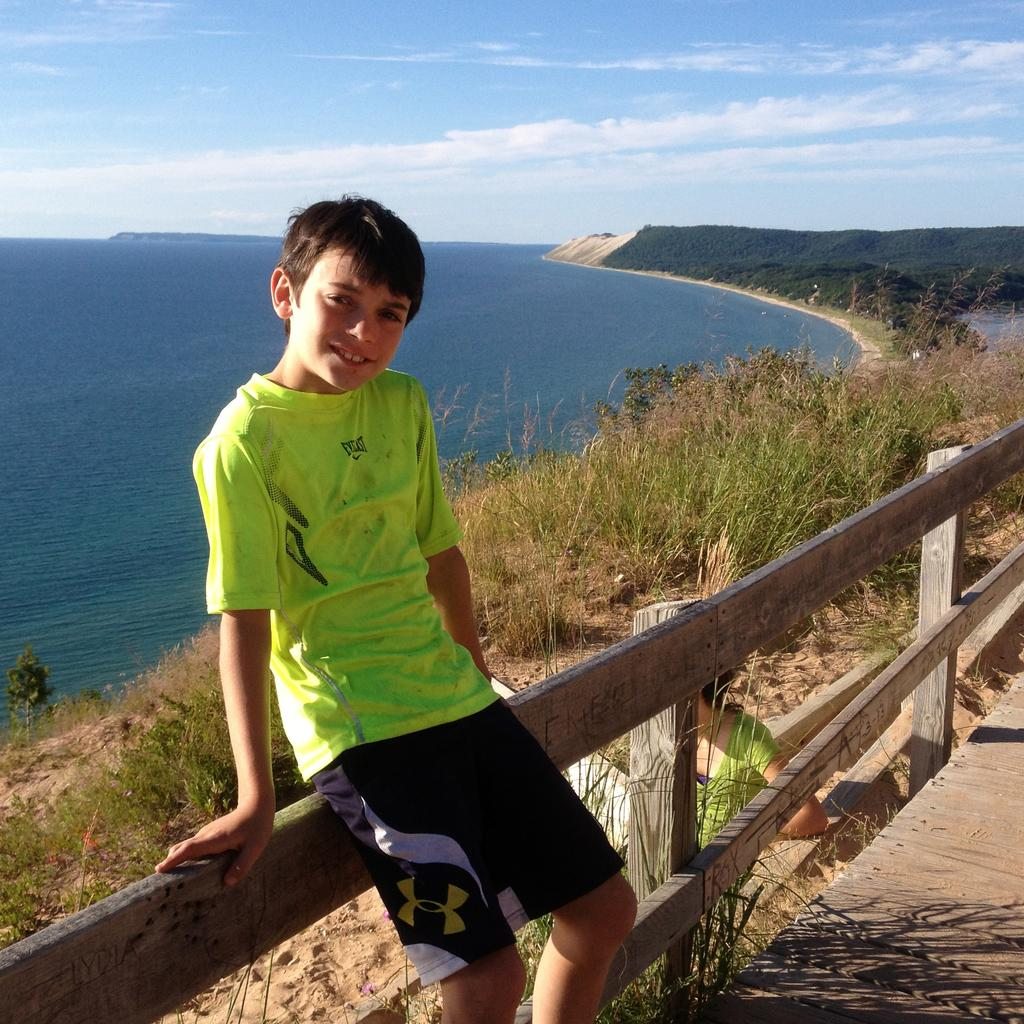<image>
Present a compact description of the photo's key features. A kid wearing a shirt that says Everlast on it with Under Armor shorts. 